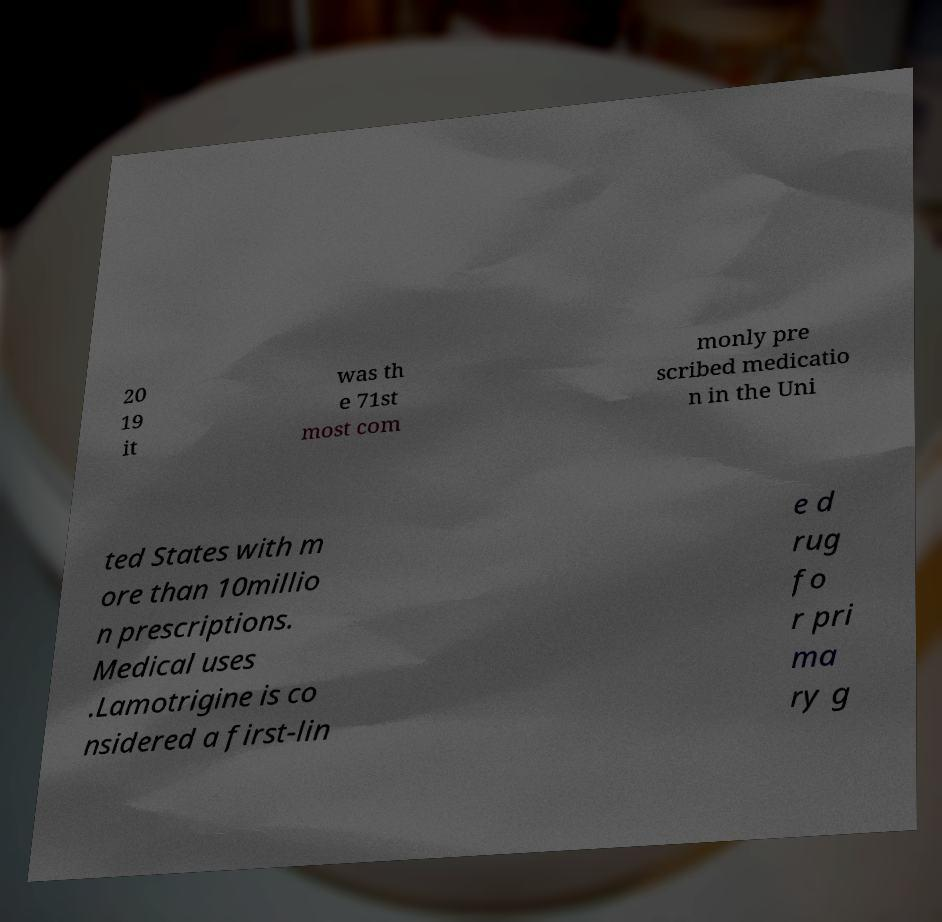Can you accurately transcribe the text from the provided image for me? 20 19 it was th e 71st most com monly pre scribed medicatio n in the Uni ted States with m ore than 10millio n prescriptions. Medical uses .Lamotrigine is co nsidered a first-lin e d rug fo r pri ma ry g 